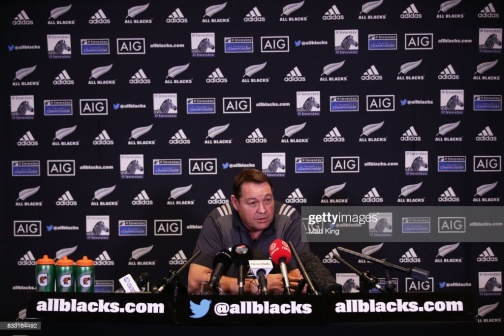Based on this image, create a long and realistic scenario of what could be happening. In a long and realistic scenario, the scene captures the aftermath of a highly anticipated final between the All Blacks and one of their greatest rivals. The press conference room is bustling with energy as journalists from various media outlets await their turn to ask questions. The man at the desk, the head coach of the All Blacks, has just led his team to a hard-fought victory. He begins with a brief statement, expressing his pride in the team's performance and acknowledging the tremendous effort of both teams. The room is filled with a sense of respect, and the coach's demeanor is one of modest satisfaction. As microphones are adjusted and cameras flash, he fields a series of questions ranging from specific game tactics to player performances. He praises a young player who made a significant impact, revealing the thought process behind key decisions made during the game. He also provides insights into how the team plans to maintain its form and manage player fitness for upcoming matches. The interaction is a mix of professional analysis and heartfelt appreciation, painting a comprehensive picture of the event for all present. 